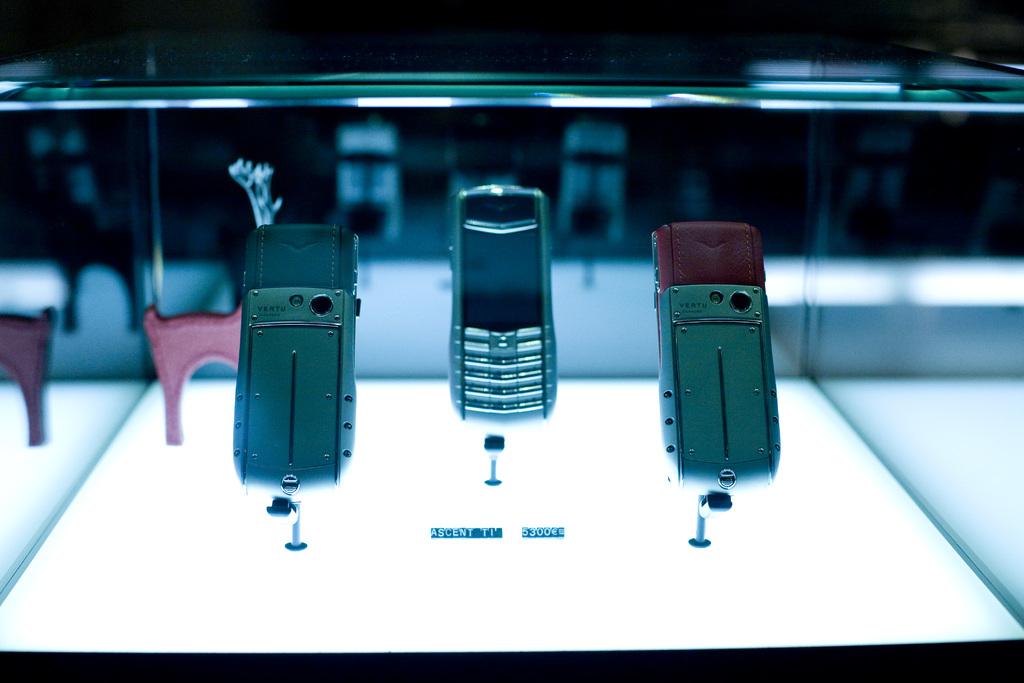What type of phone is under the case?
Your answer should be compact. Unanswerable. What is the price of the phone in the case?
Give a very brief answer. 5300. 